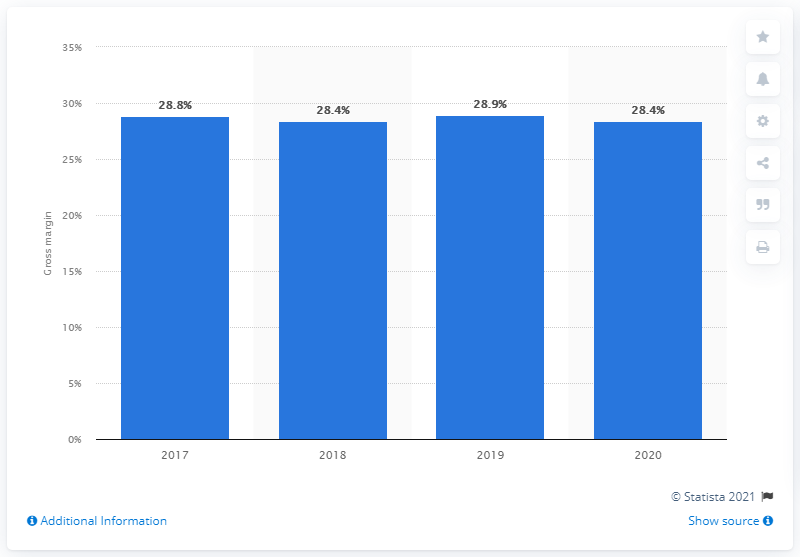Draw attention to some important aspects in this diagram. Target's gross margin in 2020 was 28.4%. Since 2017, Target's gross margin has remained stable. 